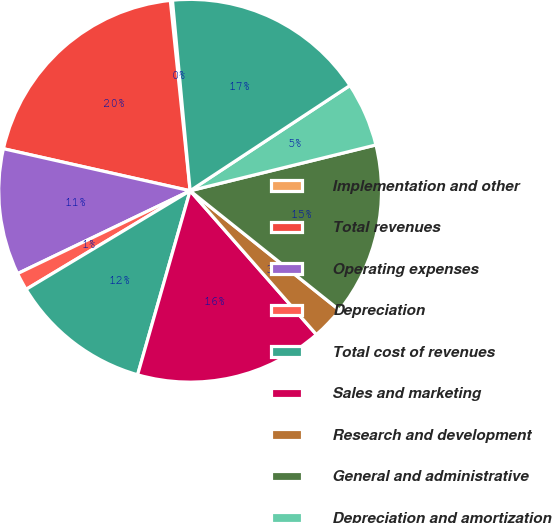<chart> <loc_0><loc_0><loc_500><loc_500><pie_chart><fcel>Implementation and other<fcel>Total revenues<fcel>Operating expenses<fcel>Depreciation<fcel>Total cost of revenues<fcel>Sales and marketing<fcel>Research and development<fcel>General and administrative<fcel>Depreciation and amortization<fcel>Total administrative expenses<nl><fcel>0.18%<fcel>19.82%<fcel>10.65%<fcel>1.49%<fcel>11.96%<fcel>15.89%<fcel>2.8%<fcel>14.58%<fcel>5.42%<fcel>17.2%<nl></chart> 